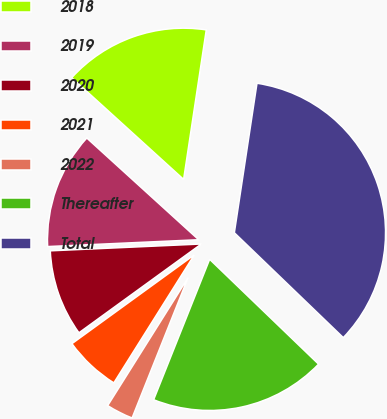Convert chart to OTSL. <chart><loc_0><loc_0><loc_500><loc_500><pie_chart><fcel>2018<fcel>2019<fcel>2020<fcel>2021<fcel>2022<fcel>Thereafter<fcel>Total<nl><fcel>15.65%<fcel>12.46%<fcel>9.27%<fcel>6.08%<fcel>2.89%<fcel>18.84%<fcel>34.8%<nl></chart> 